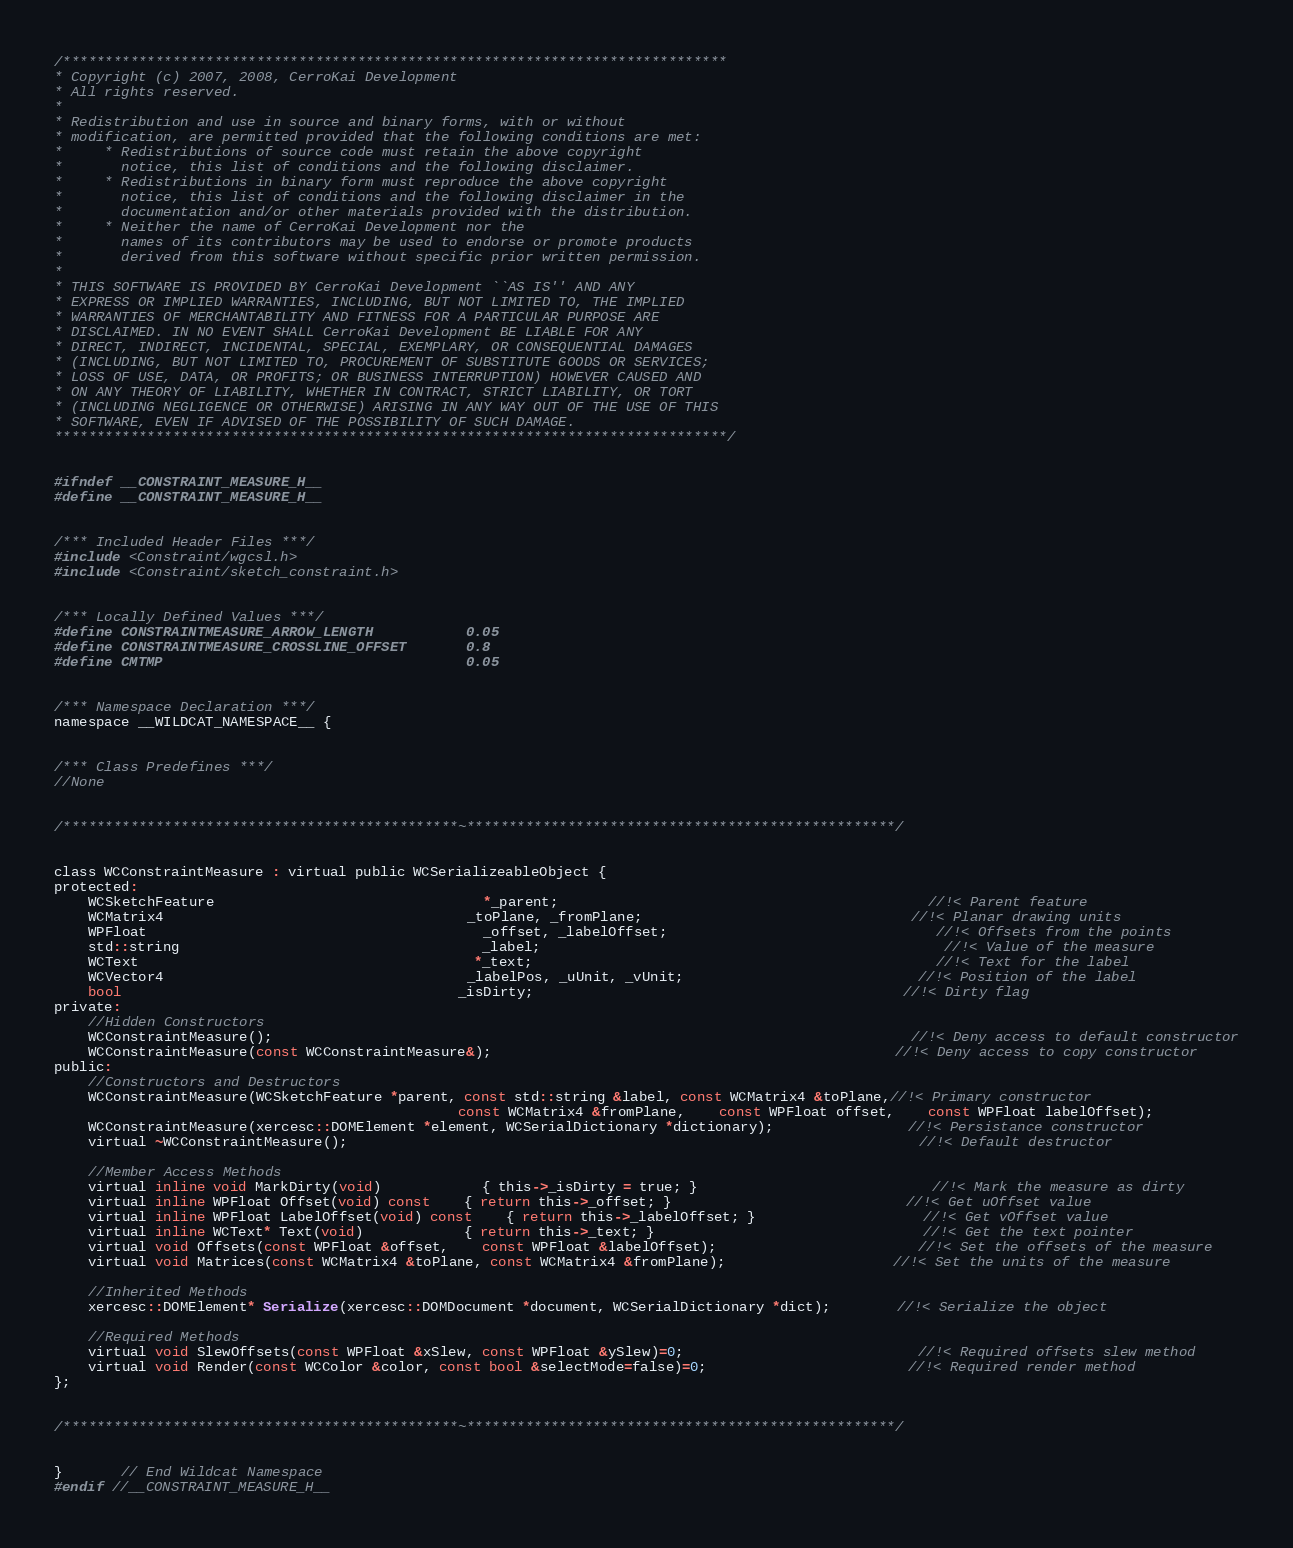Convert code to text. <code><loc_0><loc_0><loc_500><loc_500><_C_>/*******************************************************************************
* Copyright (c) 2007, 2008, CerroKai Development
* All rights reserved.
*
* Redistribution and use in source and binary forms, with or without
* modification, are permitted provided that the following conditions are met:
*     * Redistributions of source code must retain the above copyright
*       notice, this list of conditions and the following disclaimer.
*     * Redistributions in binary form must reproduce the above copyright
*       notice, this list of conditions and the following disclaimer in the
*       documentation and/or other materials provided with the distribution.
*     * Neither the name of CerroKai Development nor the
*       names of its contributors may be used to endorse or promote products
*       derived from this software without specific prior written permission.
*
* THIS SOFTWARE IS PROVIDED BY CerroKai Development ``AS IS'' AND ANY
* EXPRESS OR IMPLIED WARRANTIES, INCLUDING, BUT NOT LIMITED TO, THE IMPLIED
* WARRANTIES OF MERCHANTABILITY AND FITNESS FOR A PARTICULAR PURPOSE ARE
* DISCLAIMED. IN NO EVENT SHALL CerroKai Development BE LIABLE FOR ANY
* DIRECT, INDIRECT, INCIDENTAL, SPECIAL, EXEMPLARY, OR CONSEQUENTIAL DAMAGES
* (INCLUDING, BUT NOT LIMITED TO, PROCUREMENT OF SUBSTITUTE GOODS OR SERVICES;
* LOSS OF USE, DATA, OR PROFITS; OR BUSINESS INTERRUPTION) HOWEVER CAUSED AND
* ON ANY THEORY OF LIABILITY, WHETHER IN CONTRACT, STRICT LIABILITY, OR TORT
* (INCLUDING NEGLIGENCE OR OTHERWISE) ARISING IN ANY WAY OUT OF THE USE OF THIS
* SOFTWARE, EVEN IF ADVISED OF THE POSSIBILITY OF SUCH DAMAGE.
********************************************************************************/


#ifndef __CONSTRAINT_MEASURE_H__
#define __CONSTRAINT_MEASURE_H__


/*** Included Header Files ***/
#include <Constraint/wgcsl.h>
#include <Constraint/sketch_constraint.h>


/*** Locally Defined Values ***/
#define CONSTRAINTMEASURE_ARROW_LENGTH			0.05
#define CONSTRAINTMEASURE_CROSSLINE_OFFSET		0.8
#define CMTMP									0.05


/*** Namespace Declaration ***/
namespace __WILDCAT_NAMESPACE__ {


/*** Class Predefines ***/
//None


/***********************************************~***************************************************/


class WCConstraintMeasure : virtual public WCSerializeableObject {
protected:
	WCSketchFeature								*_parent;											//!< Parent feature
	WCMatrix4									_toPlane, _fromPlane;								//!< Planar drawing units
	WPFloat										_offset, _labelOffset;								//!< Offsets from the points
	std::string									_label;												//!< Value of the measure
	WCText										*_text;												//!< Text for the label
	WCVector4									_labelPos, _uUnit, _vUnit;							//!< Position of the label
	bool										_isDirty;											//!< Dirty flag
private:
	//Hidden Constructors
	WCConstraintMeasure();																			//!< Deny access to default constructor
	WCConstraintMeasure(const WCConstraintMeasure&);												//!< Deny access to copy constructor
public:
	//Constructors and Destructors
	WCConstraintMeasure(WCSketchFeature *parent, const std::string &label, const WCMatrix4 &toPlane,//!< Primary constructor
												const WCMatrix4 &fromPlane,	const WPFloat offset,	const WPFloat labelOffset);
	WCConstraintMeasure(xercesc::DOMElement *element, WCSerialDictionary *dictionary);				//!< Persistance constructor
	virtual ~WCConstraintMeasure();																	//!< Default destructor

	//Member Access Methods
	virtual inline void MarkDirty(void)			{ this->_isDirty = true; }							//!< Mark the measure as dirty
	virtual inline WPFloat Offset(void) const	{ return this->_offset; }							//!< Get uOffset value
	virtual inline WPFloat LabelOffset(void) const	{ return this->_labelOffset; }					//!< Get vOffset value
	virtual inline WCText* Text(void)			{ return this->_text; }								//!< Get the text pointer
	virtual void Offsets(const WPFloat &offset,	const WPFloat &labelOffset);						//!< Set the offsets of the measure
	virtual void Matrices(const WCMatrix4 &toPlane, const WCMatrix4 &fromPlane);					//!< Set the units of the measure

	//Inherited Methods
	xercesc::DOMElement* Serialize(xercesc::DOMDocument *document, WCSerialDictionary *dict);		//!< Serialize the object

	//Required Methods
	virtual void SlewOffsets(const WPFloat &xSlew, const WPFloat &ySlew)=0;							//!< Required offsets slew method
	virtual void Render(const WCColor &color, const bool &selectMode=false)=0;						//!< Required render method
};


/***********************************************~***************************************************/


}	   // End Wildcat Namespace
#endif //__CONSTRAINT_MEASURE_H__

</code> 